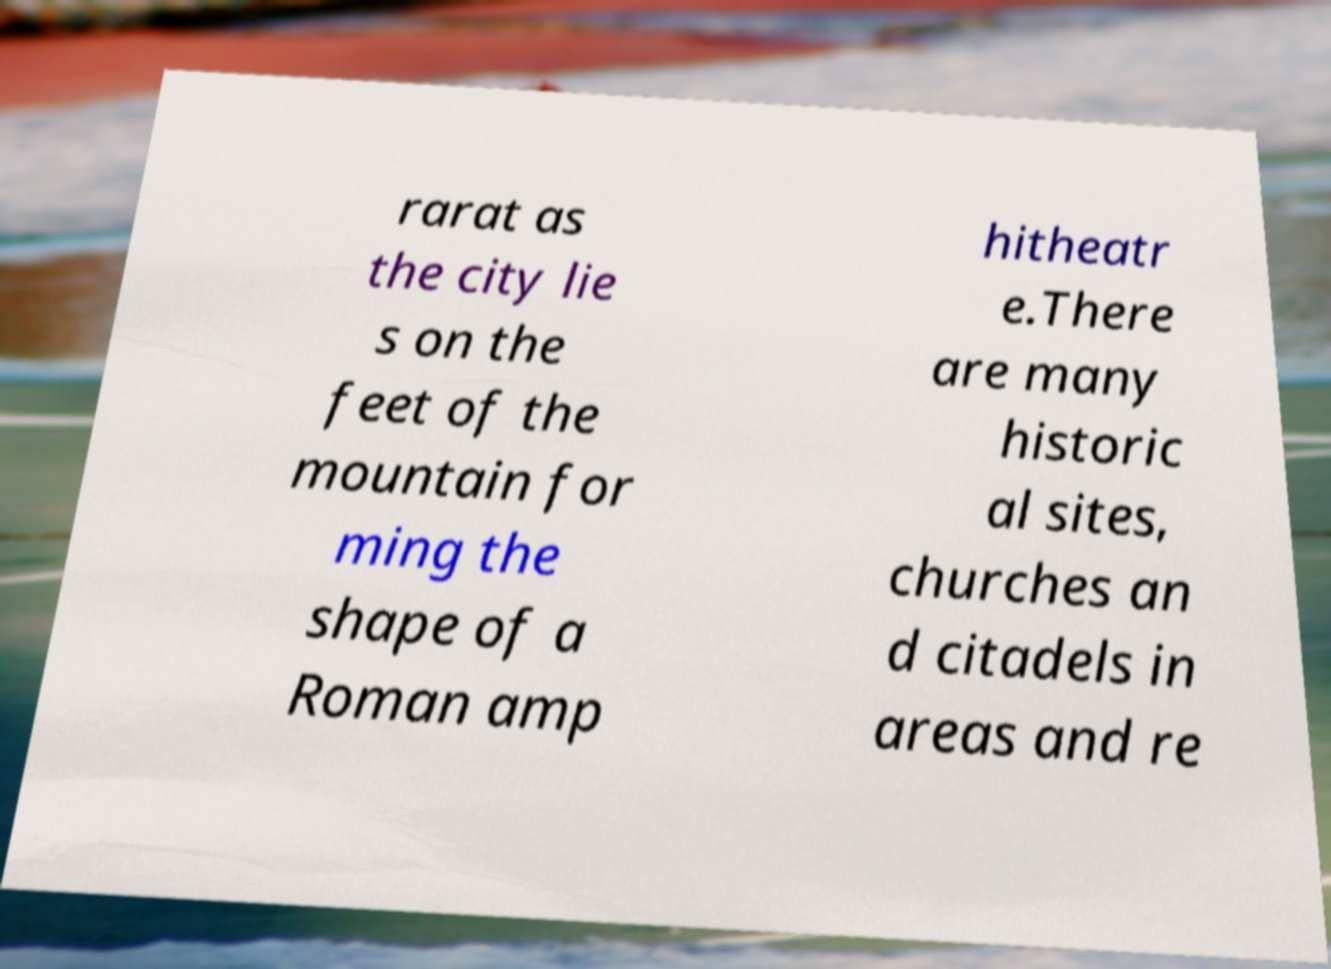Please read and relay the text visible in this image. What does it say? rarat as the city lie s on the feet of the mountain for ming the shape of a Roman amp hitheatr e.There are many historic al sites, churches an d citadels in areas and re 